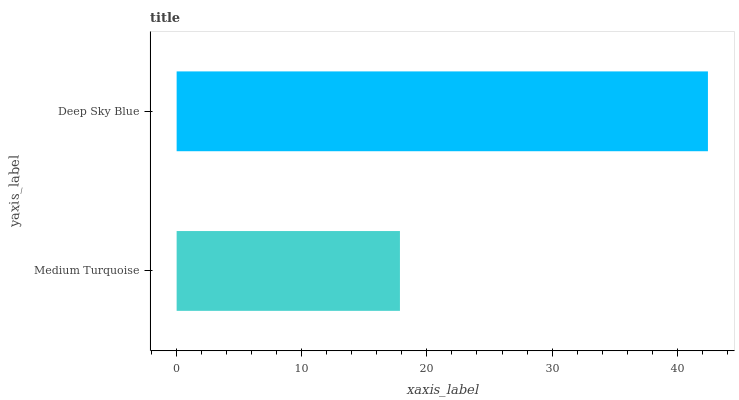Is Medium Turquoise the minimum?
Answer yes or no. Yes. Is Deep Sky Blue the maximum?
Answer yes or no. Yes. Is Deep Sky Blue the minimum?
Answer yes or no. No. Is Deep Sky Blue greater than Medium Turquoise?
Answer yes or no. Yes. Is Medium Turquoise less than Deep Sky Blue?
Answer yes or no. Yes. Is Medium Turquoise greater than Deep Sky Blue?
Answer yes or no. No. Is Deep Sky Blue less than Medium Turquoise?
Answer yes or no. No. Is Deep Sky Blue the high median?
Answer yes or no. Yes. Is Medium Turquoise the low median?
Answer yes or no. Yes. Is Medium Turquoise the high median?
Answer yes or no. No. Is Deep Sky Blue the low median?
Answer yes or no. No. 